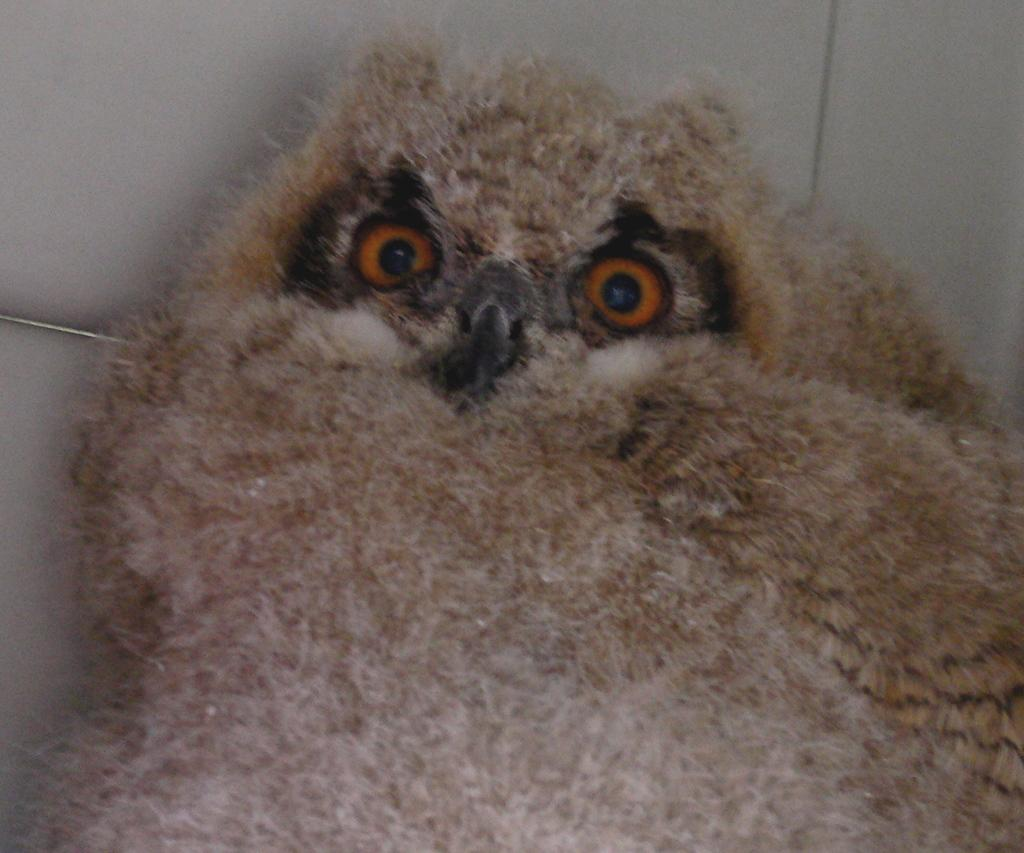What animal is featured in the picture? There is an owl in the picture. What color is the owl? The owl is light brown in color. What is the background of the picture? There is a white background in the picture. How many snakes are wrapped around the owl's nose in the image? There are no snakes present in the image, and the owl's nose is not visible. What type of shop can be seen in the background of the image? There is no shop present in the image; the background is white. 